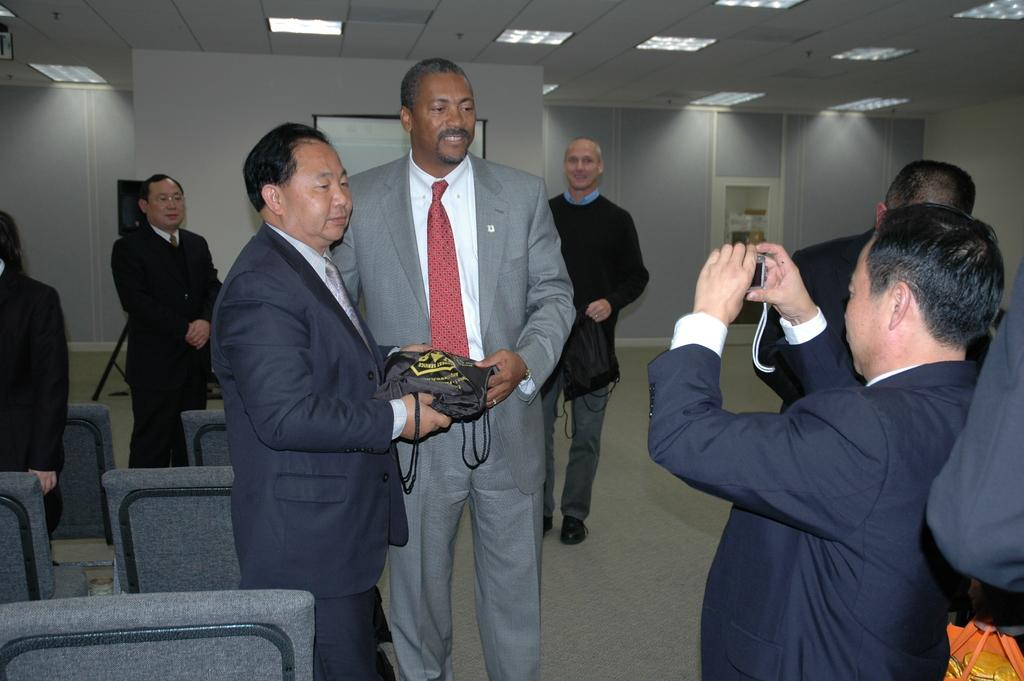What are the two persons in the image doing? The two persons are standing and holding an object. Who is holding a camera in the image? There is a person holding a camera in the image. What can be seen in the background of the image? There is a group of people standing in the background, along with lights, a door, and chairs. What type of cactus can be seen in the image? There is no cactus present in the image. Who is attempting to lead the group in the background? The image does not provide information about anyone attempting to lead the group in the background. 